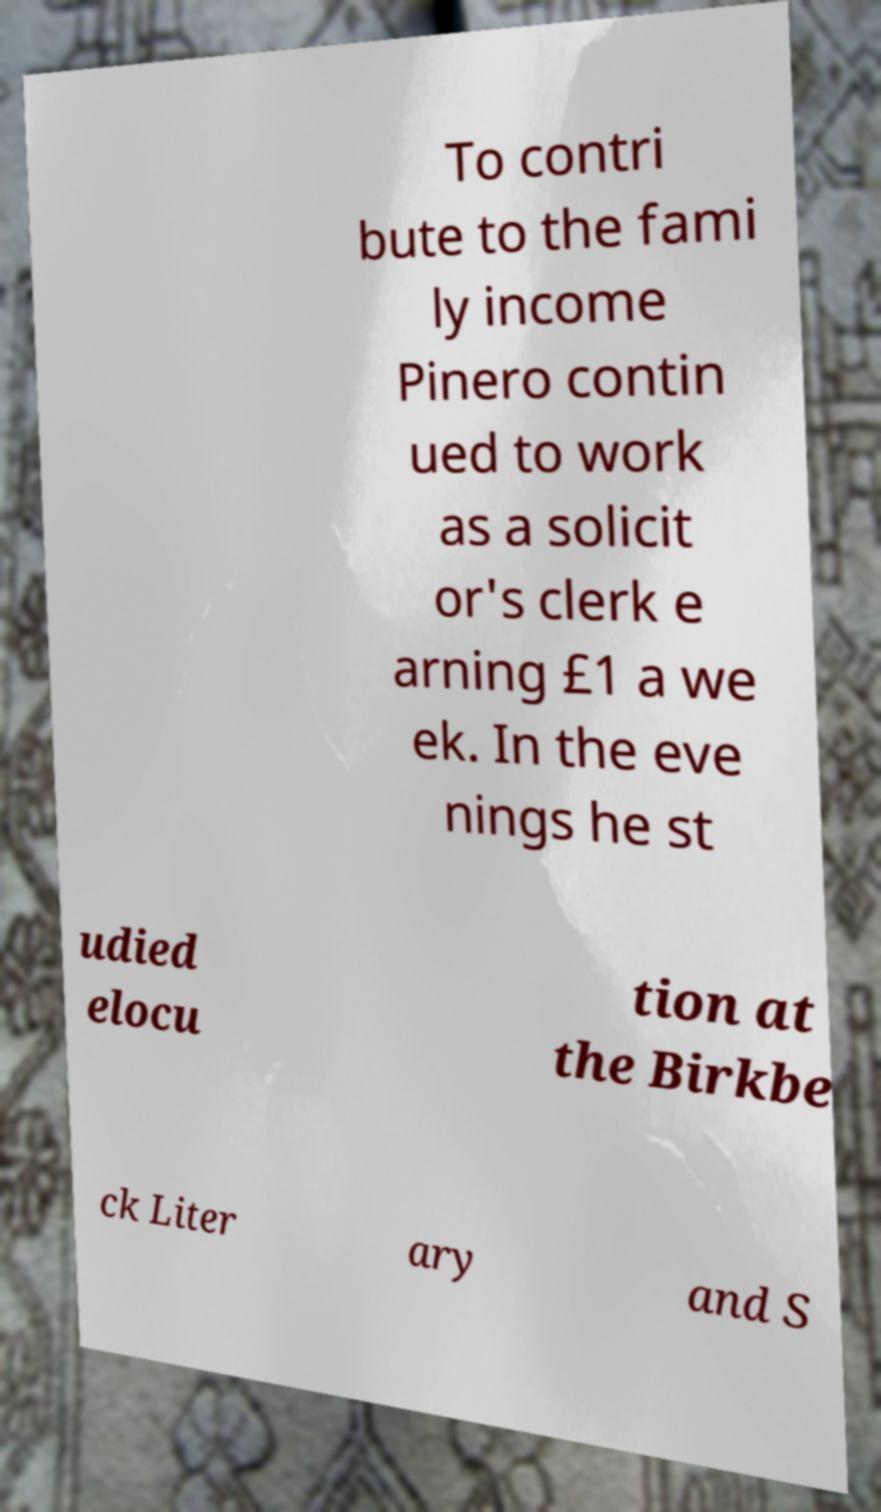For documentation purposes, I need the text within this image transcribed. Could you provide that? To contri bute to the fami ly income Pinero contin ued to work as a solicit or's clerk e arning £1 a we ek. In the eve nings he st udied elocu tion at the Birkbe ck Liter ary and S 